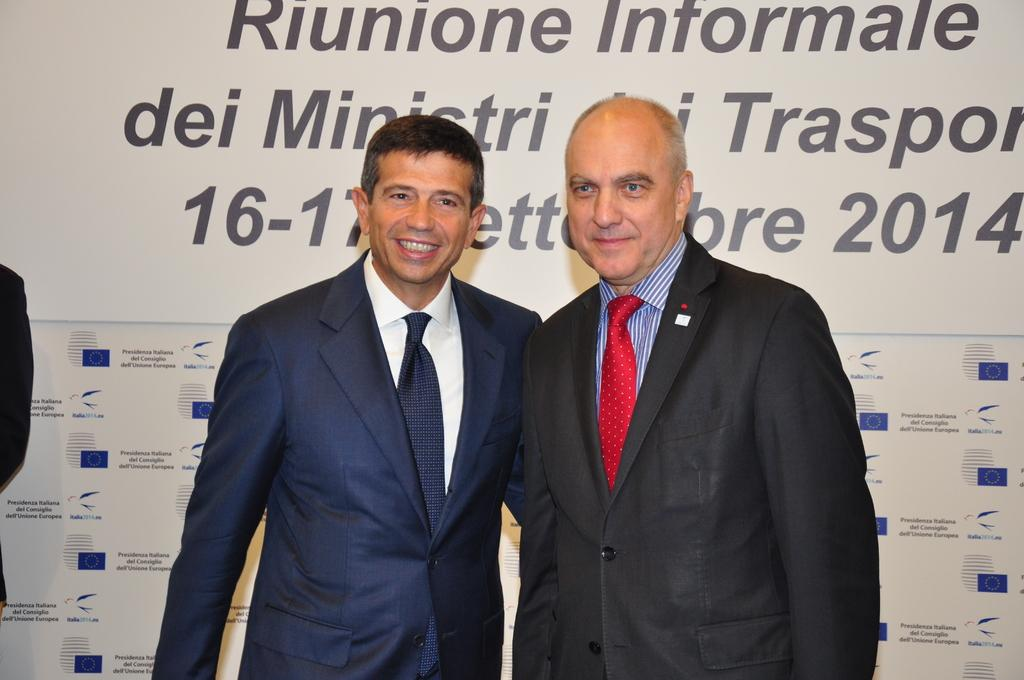How many people are in the image? There are two people standing in the image. What is the facial expression of the people in the image? The people are smiling. What can be seen in the background of the image? There is a poster in the background of the image. What types of content are present on the poster? The poster contains text and images. Are there any bushes or snails visible in the image? No, there are no bushes or snails present in the image. Is there a volcano erupting in the background of the image? No, there is no volcano or any indication of an eruption in the image. 